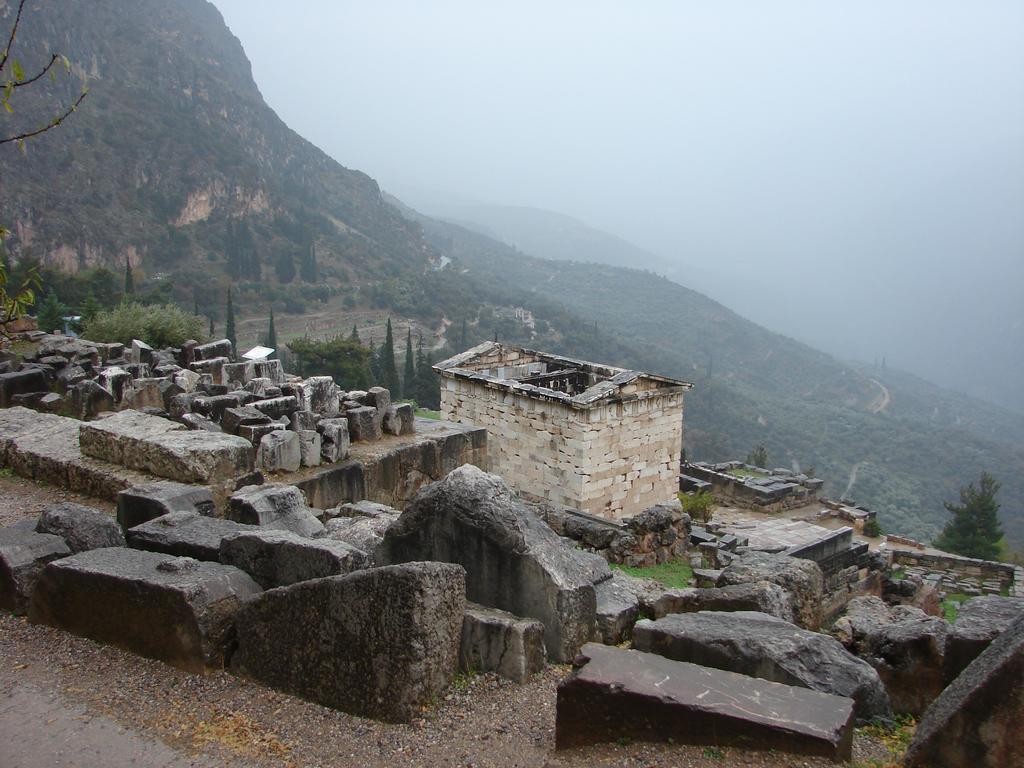Could you give a brief overview of what you see in this image? There are stones and house structure in the foreground area, there is greenery, mountains, it seems like smoke and the sky in the background. 